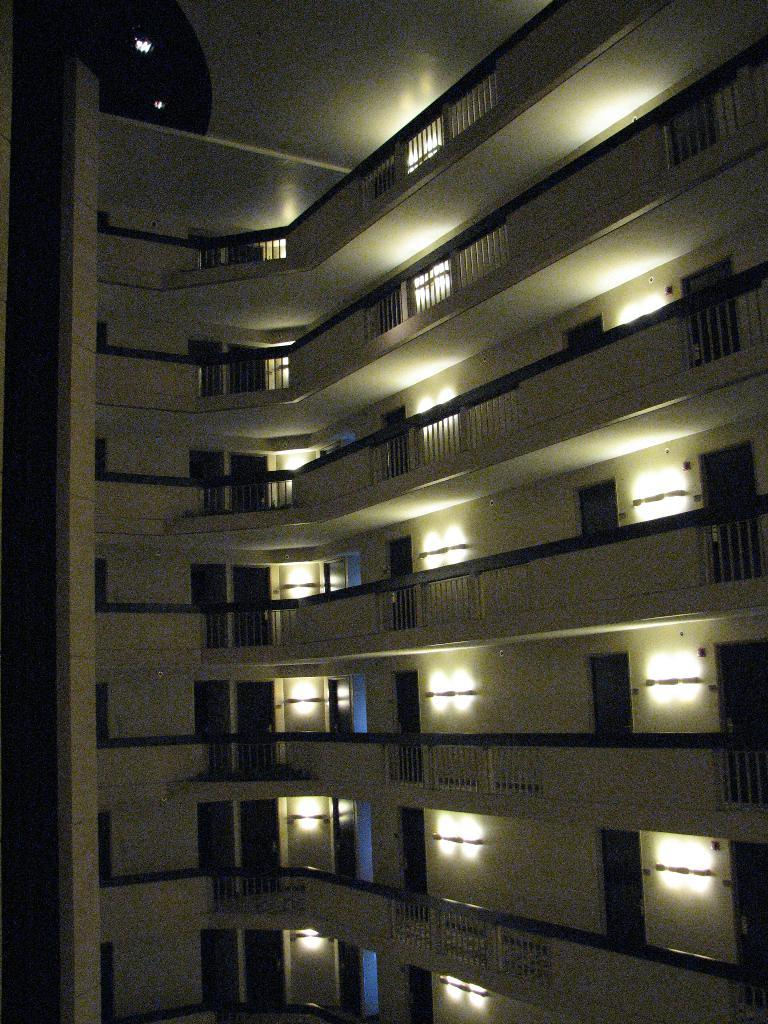What type of structure is visible in the image? There is a building in the image. Can you describe any features near the building? There is a railing near the building. What can be seen on the wall of the building? There are many lights on the wall of the building. How can people enter the building? There are doors to the building. How many fish are swimming in the crowd near the building? There are no fish or crowds present in the image; it only features a building with lights, a railing, and doors. 